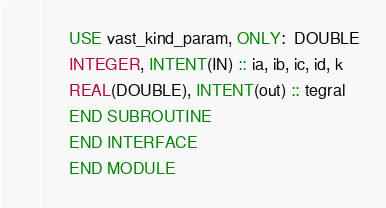<code> <loc_0><loc_0><loc_500><loc_500><_FORTRAN_>      USE vast_kind_param, ONLY:  DOUBLE
      INTEGER, INTENT(IN) :: ia, ib, ic, id, k
      REAL(DOUBLE), INTENT(out) :: tegral
      END SUBROUTINE
      END INTERFACE
      END MODULE
</code> 